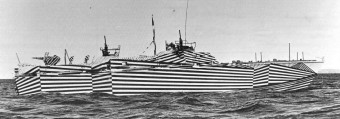How many boats would there be in the image if one additional boat was added in the scene? If we were to add one more boat to the scene, the total number of boats would be four, creating an even more impressive display of these distinctive, camouflage-painted vessels known as 'dazzle ships,' which were used during World War I to make it difficult for enemies to estimate their speed and heading. 